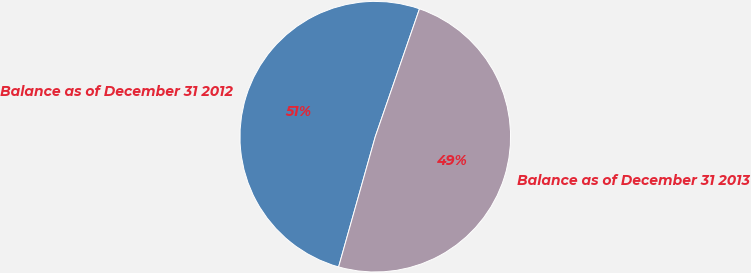Convert chart to OTSL. <chart><loc_0><loc_0><loc_500><loc_500><pie_chart><fcel>Balance as of December 31 2012<fcel>Balance as of December 31 2013<nl><fcel>50.93%<fcel>49.07%<nl></chart> 